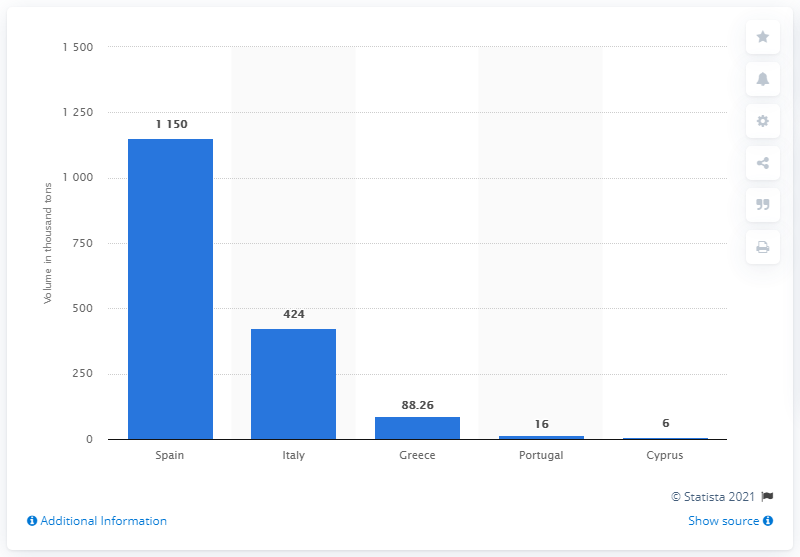Highlight a few significant elements in this photo. The country that produced the largest quantity of fresh lemons in the 2018/19 season was Spain. 